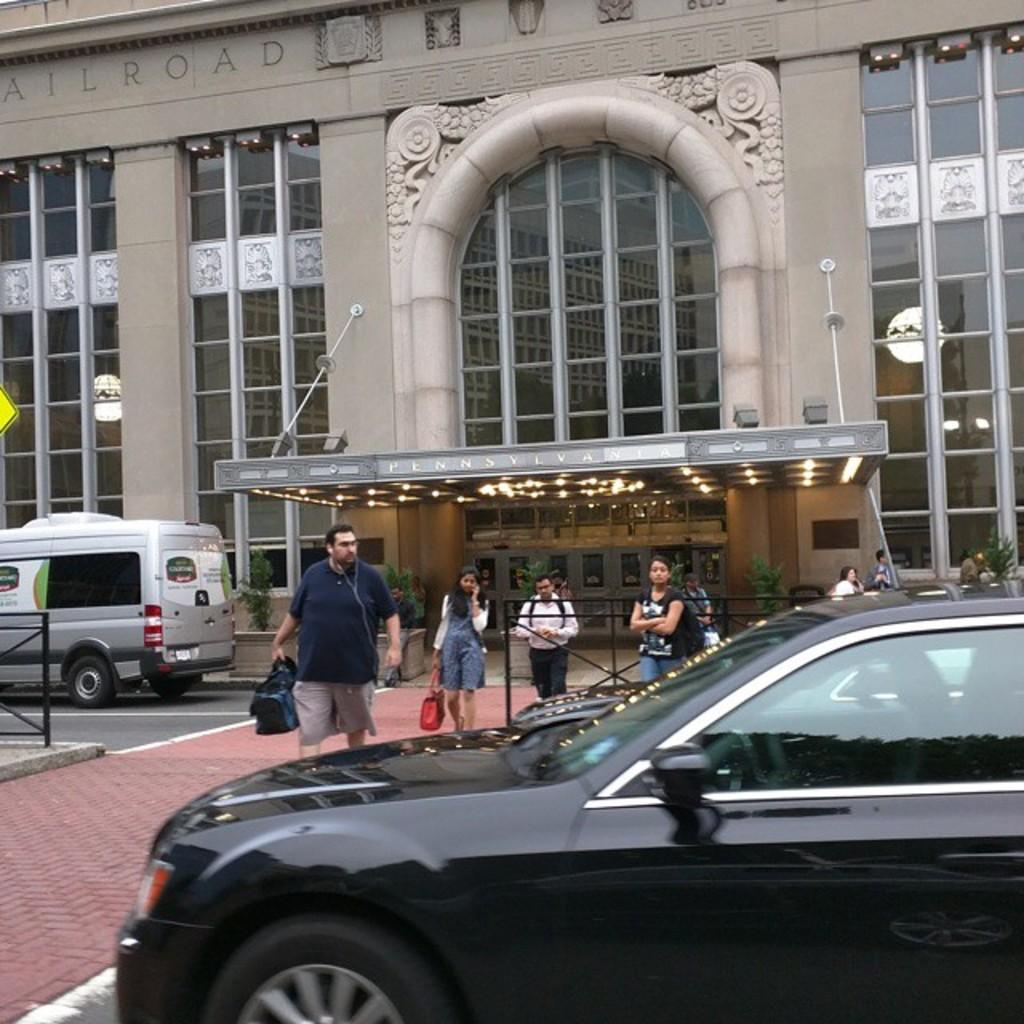What are the people in the image doing? The people in the image are walking. What color is the path they are walking on? The path they are walking on is red. What can be seen in the background of the image? There is a building in the image. What features does the building have? The building has lights, glass windows, and doors. What else can be seen on the road in the image? There are vehicles on either side of the road. What type of treatment is being administered inside the tent in the image? There is no tent present in the image, so no treatment can be administered inside it. 